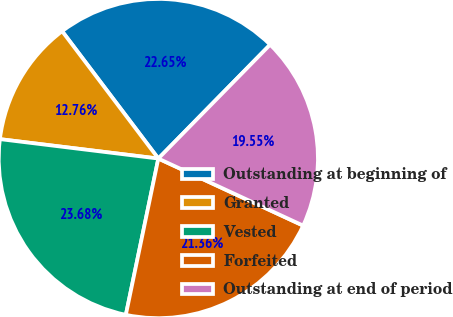Convert chart to OTSL. <chart><loc_0><loc_0><loc_500><loc_500><pie_chart><fcel>Outstanding at beginning of<fcel>Granted<fcel>Vested<fcel>Forfeited<fcel>Outstanding at end of period<nl><fcel>22.65%<fcel>12.76%<fcel>23.68%<fcel>21.36%<fcel>19.55%<nl></chart> 